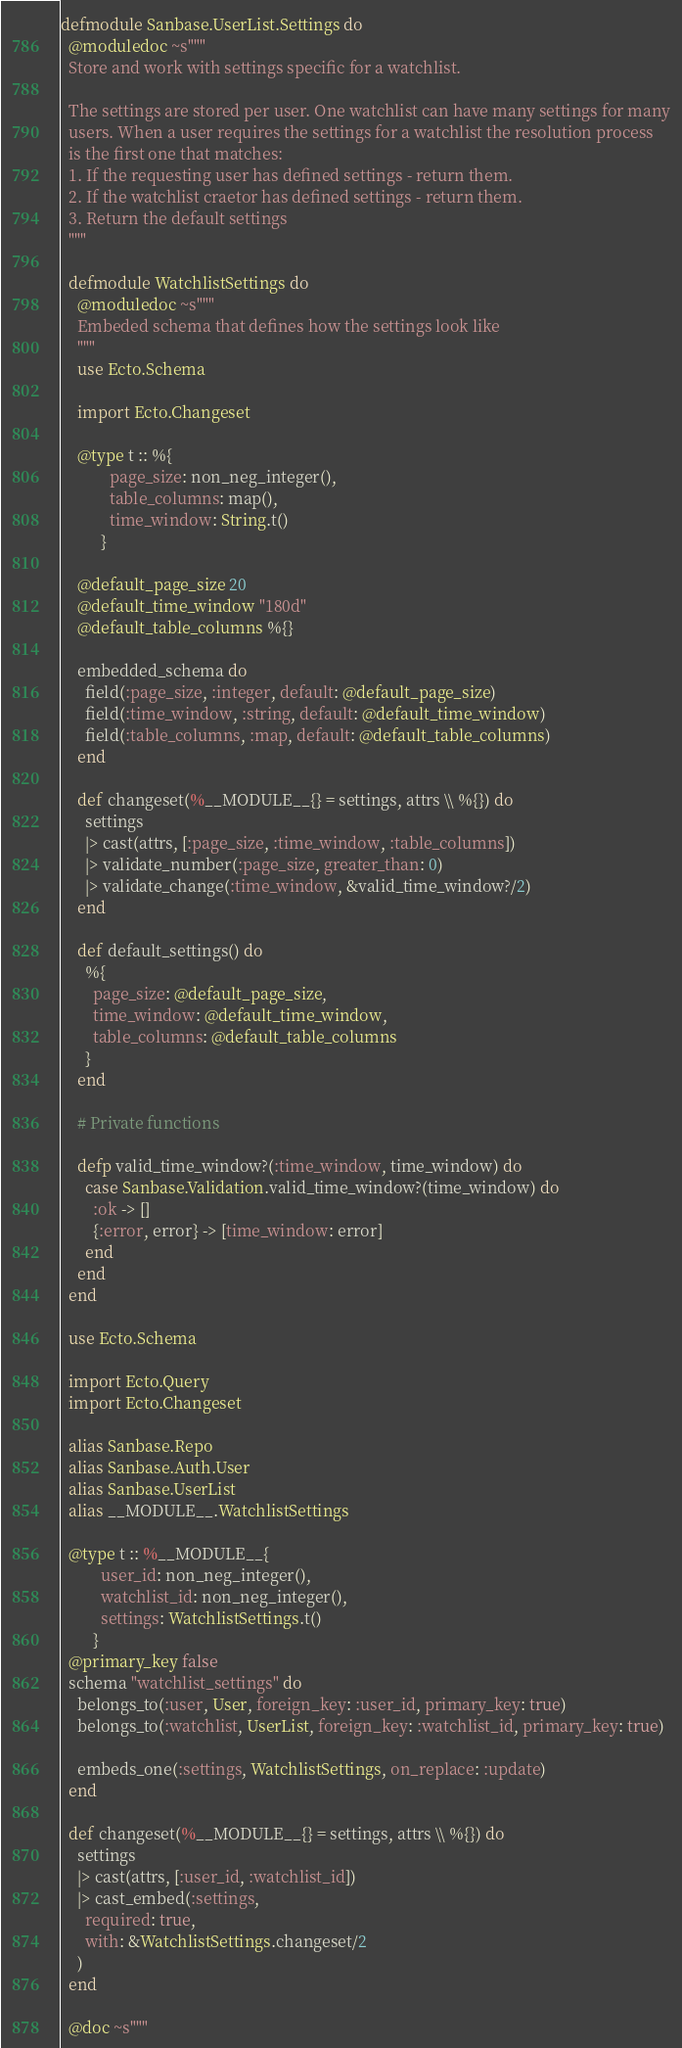Convert code to text. <code><loc_0><loc_0><loc_500><loc_500><_Elixir_>defmodule Sanbase.UserList.Settings do
  @moduledoc ~s"""
  Store and work with settings specific for a watchlist.

  The settings are stored per user. One watchlist can have many settings for many
  users. When a user requires the settings for a watchlist the resolution process
  is the first one that matches:
  1. If the requesting user has defined settings - return them.
  2. If the watchlist craetor has defined settings - return them.
  3. Return the default settings
  """

  defmodule WatchlistSettings do
    @moduledoc ~s"""
    Embeded schema that defines how the settings look like
    """
    use Ecto.Schema

    import Ecto.Changeset

    @type t :: %{
            page_size: non_neg_integer(),
            table_columns: map(),
            time_window: String.t()
          }

    @default_page_size 20
    @default_time_window "180d"
    @default_table_columns %{}

    embedded_schema do
      field(:page_size, :integer, default: @default_page_size)
      field(:time_window, :string, default: @default_time_window)
      field(:table_columns, :map, default: @default_table_columns)
    end

    def changeset(%__MODULE__{} = settings, attrs \\ %{}) do
      settings
      |> cast(attrs, [:page_size, :time_window, :table_columns])
      |> validate_number(:page_size, greater_than: 0)
      |> validate_change(:time_window, &valid_time_window?/2)
    end

    def default_settings() do
      %{
        page_size: @default_page_size,
        time_window: @default_time_window,
        table_columns: @default_table_columns
      }
    end

    # Private functions

    defp valid_time_window?(:time_window, time_window) do
      case Sanbase.Validation.valid_time_window?(time_window) do
        :ok -> []
        {:error, error} -> [time_window: error]
      end
    end
  end

  use Ecto.Schema

  import Ecto.Query
  import Ecto.Changeset

  alias Sanbase.Repo
  alias Sanbase.Auth.User
  alias Sanbase.UserList
  alias __MODULE__.WatchlistSettings

  @type t :: %__MODULE__{
          user_id: non_neg_integer(),
          watchlist_id: non_neg_integer(),
          settings: WatchlistSettings.t()
        }
  @primary_key false
  schema "watchlist_settings" do
    belongs_to(:user, User, foreign_key: :user_id, primary_key: true)
    belongs_to(:watchlist, UserList, foreign_key: :watchlist_id, primary_key: true)

    embeds_one(:settings, WatchlistSettings, on_replace: :update)
  end

  def changeset(%__MODULE__{} = settings, attrs \\ %{}) do
    settings
    |> cast(attrs, [:user_id, :watchlist_id])
    |> cast_embed(:settings,
      required: true,
      with: &WatchlistSettings.changeset/2
    )
  end

  @doc ~s"""</code> 